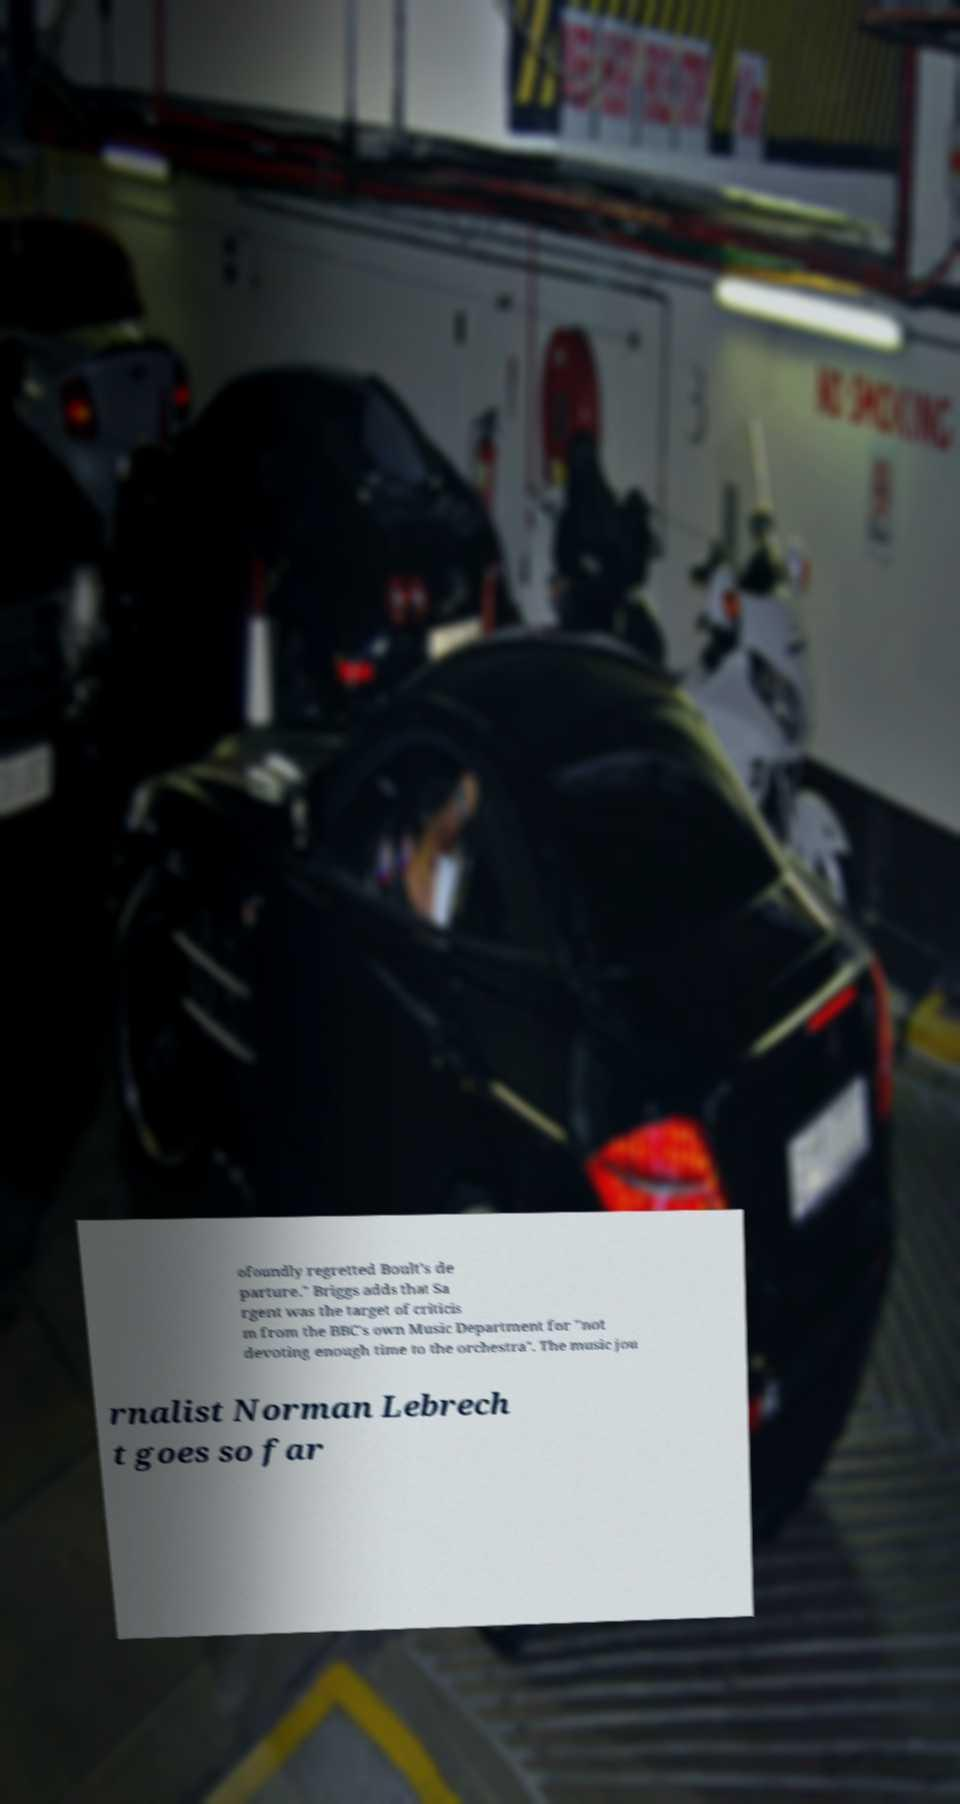Could you assist in decoding the text presented in this image and type it out clearly? ofoundly regretted Boult's de parture." Briggs adds that Sa rgent was the target of criticis m from the BBC's own Music Department for "not devoting enough time to the orchestra". The music jou rnalist Norman Lebrech t goes so far 